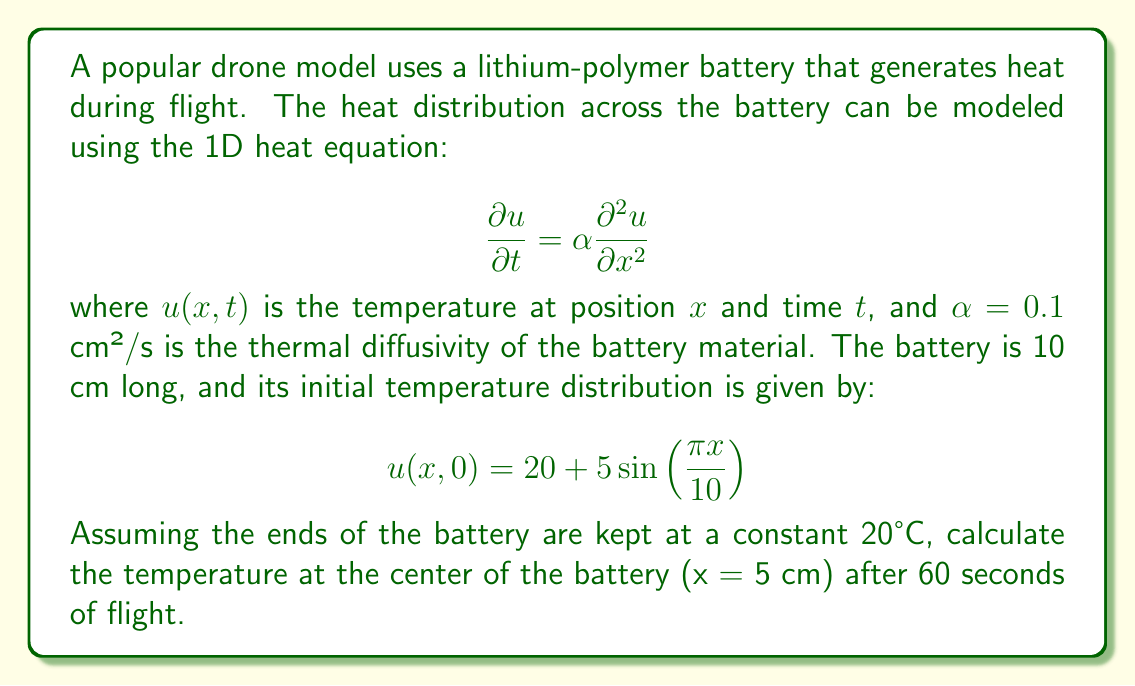Help me with this question. To solve this problem, we need to use the separation of variables method for the heat equation with the given initial and boundary conditions. Let's follow these steps:

1) The general solution for the heat equation with these boundary conditions is:

   $$u(x,t) = \sum_{n=1}^{\infty} B_n \sin(\frac{n\pi x}{L})e^{-\alpha(\frac{n\pi}{L})^2t}$$

   where $L = 10$ cm is the length of the battery.

2) We need to find $B_n$ using the initial condition:

   $$20 + 5\sin(\frac{\pi x}{10}) = \sum_{n=1}^{\infty} B_n \sin(\frac{n\pi x}{10})$$

3) This implies that $B_1 = 5$ and $B_n = 0$ for $n > 1$.

4) Therefore, our solution simplifies to:

   $$u(x,t) = 20 + 5\sin(\frac{\pi x}{10})e^{-\alpha(\frac{\pi}{10})^2t}$$

5) Now, we need to calculate $u(5,60)$:

   $$u(5,60) = 20 + 5\sin(\frac{\pi \cdot 5}{10})e^{-0.1(\frac{\pi}{10})^2 \cdot 60}$$

6) Simplify:
   
   $$u(5,60) = 20 + 5 \cdot 1 \cdot e^{-0.1(\frac{\pi^2}{100}) \cdot 60}$$
   
   $$u(5,60) = 20 + 5e^{-0.1\pi^2 \cdot 0.6}$$
   
   $$u(5,60) = 20 + 5e^{-0.18845}$$
   
   $$u(5,60) = 20 + 5 \cdot 0.82822$$
   
   $$u(5,60) = 20 + 4.1411$$
   
   $$u(5,60) = 24.1411$$

7) Rounding to two decimal places:

   $$u(5,60) \approx 24.14°C$$
Answer: 24.14°C 